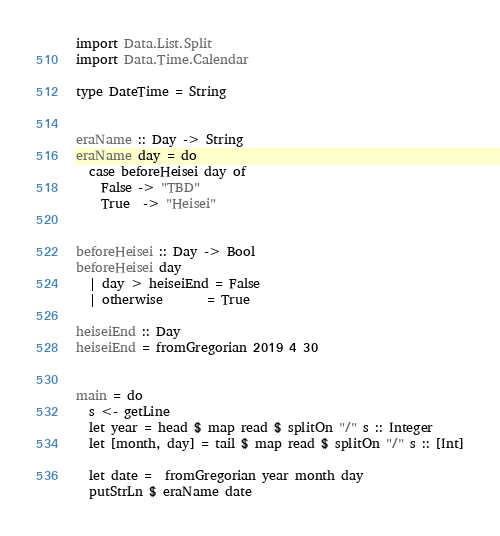Convert code to text. <code><loc_0><loc_0><loc_500><loc_500><_Haskell_>
import Data.List.Split
import Data.Time.Calendar

type DateTime = String


eraName :: Day -> String
eraName day = do
  case beforeHeisei day of
    False -> "TBD"
    True  -> "Heisei"
  

beforeHeisei :: Day -> Bool
beforeHeisei day
  | day > heiseiEnd = False
  | otherwise       = True 

heiseiEnd :: Day
heiseiEnd = fromGregorian 2019 4 30


main = do
  s <- getLine
  let year = head $ map read $ splitOn "/" s :: Integer
  let [month, day] = tail $ map read $ splitOn "/" s :: [Int]
  
  let date =  fromGregorian year month day
  putStrLn $ eraName date
</code> 